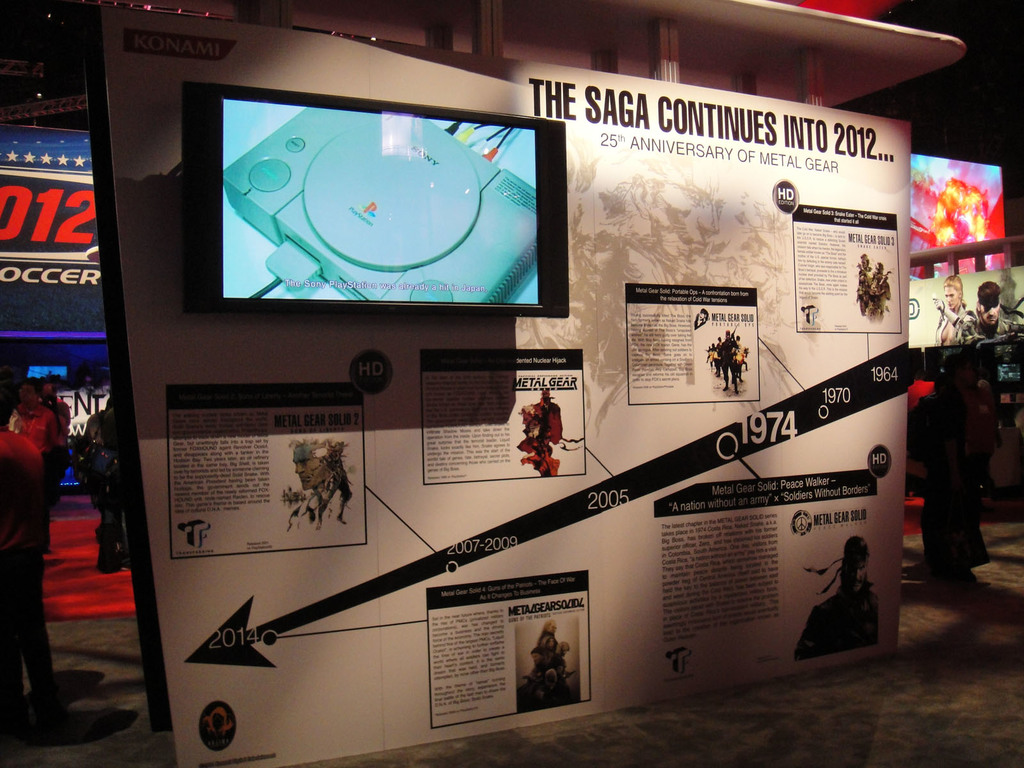Describe the visual design elements used in this exhibition. The exhibition utilizes a large, visually arresting backlit display featuring a chronological timeline. Multimedia elements such as a large screen displaying game footage and panels with high-contrast images and bold text are used to enhance viewer engagement. How does the exhibition engage the viewers through the displayed items? The exhibition engages viewers through a mixture of text, images, and video content that provides a comprehensive overview of the Metal Gear series, allowing attendees to observe game art, historical context, and notable game features directly. 